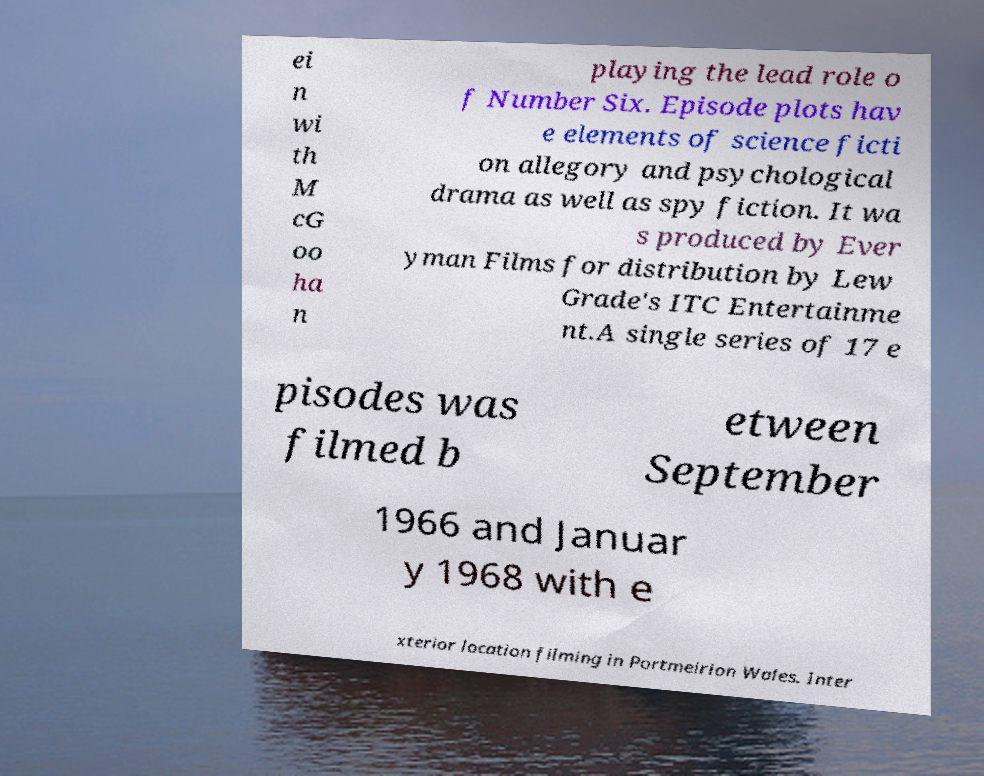For documentation purposes, I need the text within this image transcribed. Could you provide that? ei n wi th M cG oo ha n playing the lead role o f Number Six. Episode plots hav e elements of science ficti on allegory and psychological drama as well as spy fiction. It wa s produced by Ever yman Films for distribution by Lew Grade's ITC Entertainme nt.A single series of 17 e pisodes was filmed b etween September 1966 and Januar y 1968 with e xterior location filming in Portmeirion Wales. Inter 